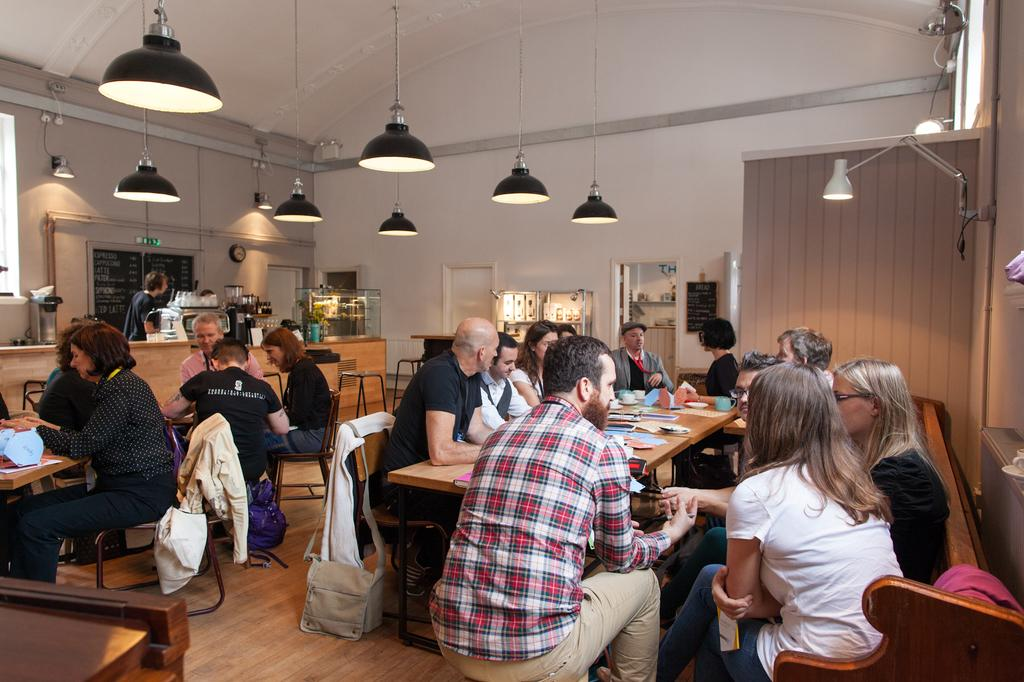What is the main activity being depicted in the image? Many people are sitting on chairs, which suggests a meeting or gathering. What is the central object in the image? There is a table in the image. What is placed on the table? Papers are present on the table. Where is the board located in the image? There is a board in the left corner of the image. What is the person standing near the board doing? It is not clear from the image what the person standing near the board is doing. What type of waves can be seen crashing on the shore in the image? There are no waves or shore visible in the image; it depicts a scene with people sitting on chairs, a table, papers, a board, and a person standing near the board. 